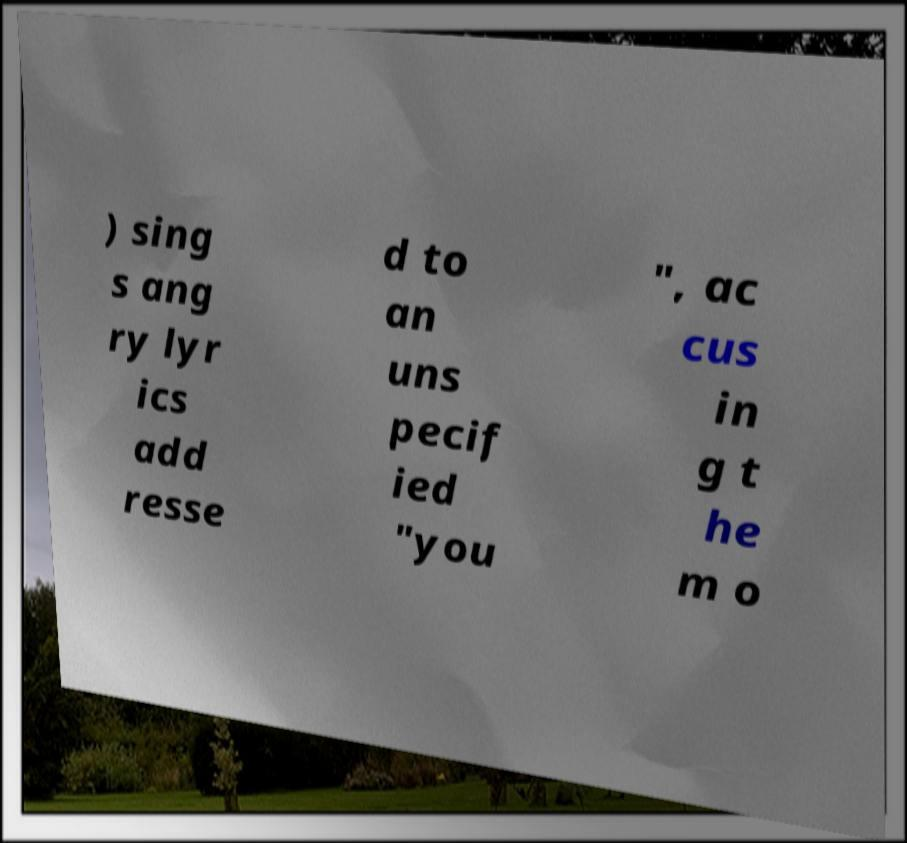Can you read and provide the text displayed in the image?This photo seems to have some interesting text. Can you extract and type it out for me? ) sing s ang ry lyr ics add resse d to an uns pecif ied "you ", ac cus in g t he m o 